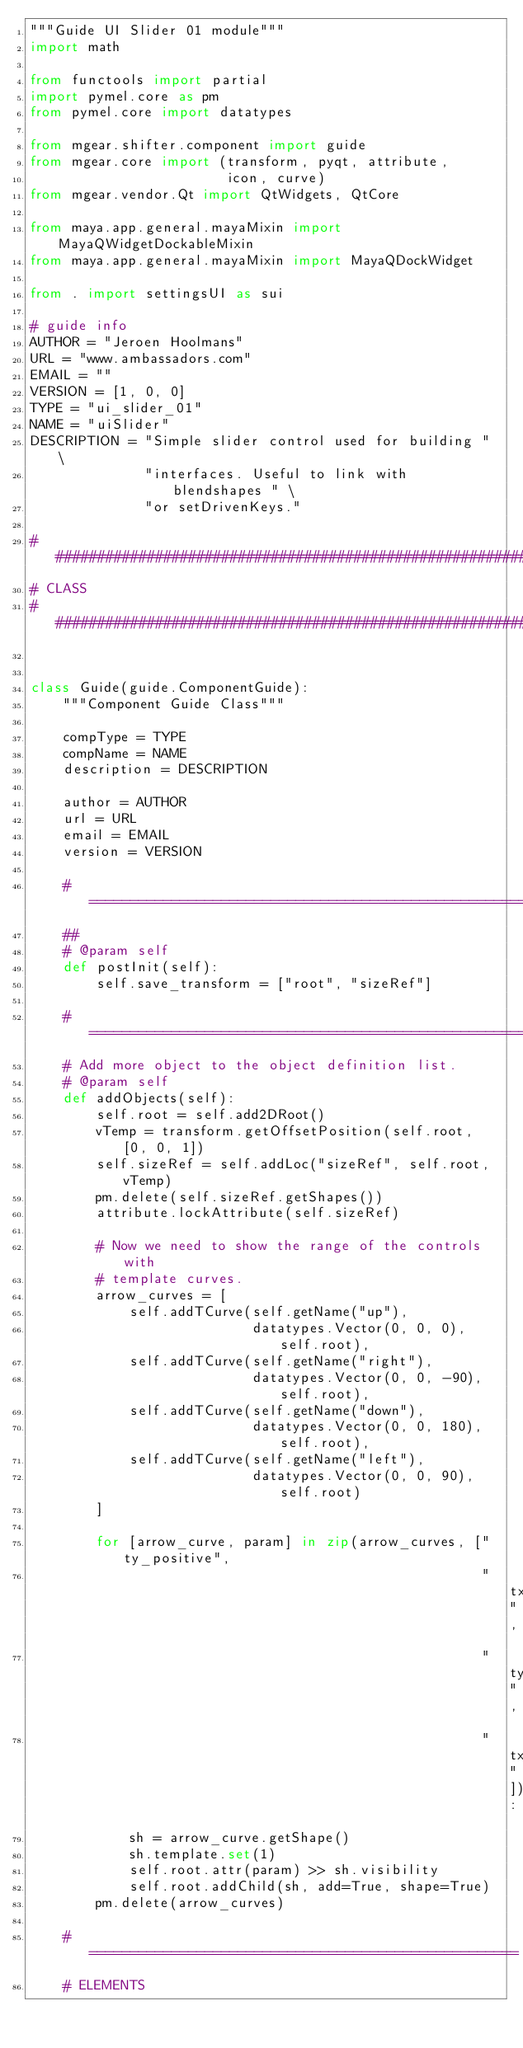Convert code to text. <code><loc_0><loc_0><loc_500><loc_500><_Python_>"""Guide UI Slider 01 module"""
import math

from functools import partial
import pymel.core as pm
from pymel.core import datatypes

from mgear.shifter.component import guide
from mgear.core import (transform, pyqt, attribute,
                        icon, curve)
from mgear.vendor.Qt import QtWidgets, QtCore

from maya.app.general.mayaMixin import MayaQWidgetDockableMixin
from maya.app.general.mayaMixin import MayaQDockWidget

from . import settingsUI as sui

# guide info
AUTHOR = "Jeroen Hoolmans"
URL = "www.ambassadors.com"
EMAIL = ""
VERSION = [1, 0, 0]
TYPE = "ui_slider_01"
NAME = "uiSlider"
DESCRIPTION = "Simple slider control used for building " \
              "interfaces. Useful to link with blendshapes " \
              "or setDrivenKeys."

##########################################################
# CLASS
##########################################################


class Guide(guide.ComponentGuide):
    """Component Guide Class"""

    compType = TYPE
    compName = NAME
    description = DESCRIPTION

    author = AUTHOR
    url = URL
    email = EMAIL
    version = VERSION

    # =====================================================
    ##
    # @param self
    def postInit(self):
        self.save_transform = ["root", "sizeRef"]

    # =====================================================
    # Add more object to the object definition list.
    # @param self
    def addObjects(self):
        self.root = self.add2DRoot()
        vTemp = transform.getOffsetPosition(self.root, [0, 0, 1])
        self.sizeRef = self.addLoc("sizeRef", self.root, vTemp)
        pm.delete(self.sizeRef.getShapes())
        attribute.lockAttribute(self.sizeRef)

        # Now we need to show the range of the controls with
        # template curves.
        arrow_curves = [
            self.addTCurve(self.getName("up"),
                           datatypes.Vector(0, 0, 0), self.root),
            self.addTCurve(self.getName("right"),
                           datatypes.Vector(0, 0, -90), self.root),
            self.addTCurve(self.getName("down"),
                           datatypes.Vector(0, 0, 180), self.root),
            self.addTCurve(self.getName("left"),
                           datatypes.Vector(0, 0, 90), self.root)
        ]

        for [arrow_curve, param] in zip(arrow_curves, ["ty_positive",
                                                       "tx_positive",
                                                       "ty_negative",
                                                       "tx_negative"]):
            sh = arrow_curve.getShape()
            sh.template.set(1)
            self.root.attr(param) >> sh.visibility
            self.root.addChild(sh, add=True, shape=True)
        pm.delete(arrow_curves)

    # ====================================================
    # ELEMENTS
</code> 